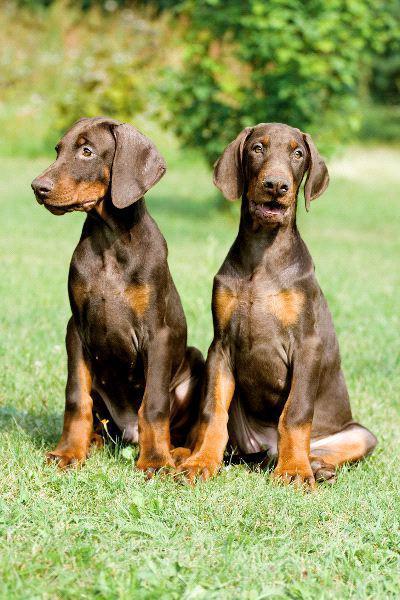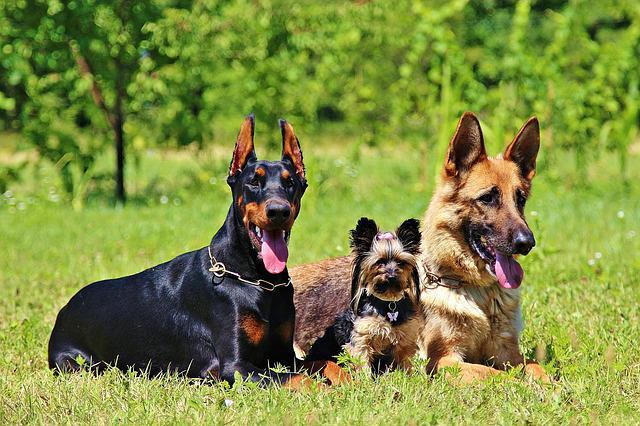The first image is the image on the left, the second image is the image on the right. Considering the images on both sides, is "There is a total of two brown dogs." valid? Answer yes or no. No. The first image is the image on the left, the second image is the image on the right. For the images shown, is this caption "There are exactly two dogs." true? Answer yes or no. No. 